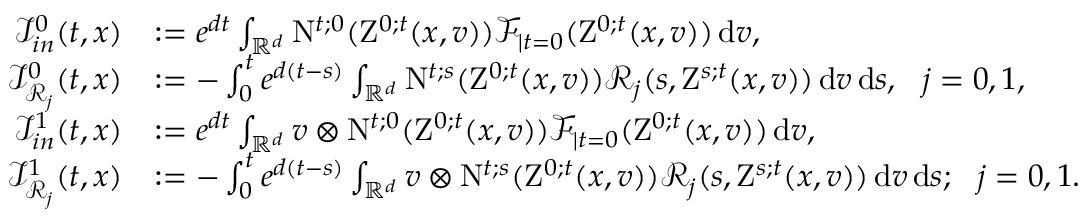Convert formula to latex. <formula><loc_0><loc_0><loc_500><loc_500>\begin{array} { r l } { \mathcal { I } _ { i n } ^ { 0 } ( t , x ) } & { \colon = e ^ { d t } \int _ { \mathbb { R } ^ { d } } N ^ { t ; 0 } ( Z ^ { 0 ; t } ( x , v ) ) \mathcal { F } _ { | t = 0 } ( Z ^ { 0 ; t } ( x , v ) ) \, d v , } \\ { \mathcal { I } _ { \mathcal { R } _ { j } } ^ { 0 } ( t , x ) } & { \colon = - \int _ { 0 } ^ { t } e ^ { d ( t - s ) } \int _ { \mathbb { R } ^ { d } } N ^ { t ; s } ( Z ^ { 0 ; t } ( x , v ) ) \mathcal { R } _ { j } ( s , Z ^ { s ; t } ( x , v ) ) \, d v \, d s , \ \ j = 0 , 1 , } \\ { \mathcal { I } _ { i n } ^ { 1 } ( t , x ) } & { \colon = e ^ { d t } \int _ { \mathbb { R } ^ { d } } v \otimes N ^ { t ; 0 } ( Z ^ { 0 ; t } ( x , v ) ) \mathcal { F } _ { | t = 0 } ( Z ^ { 0 ; t } ( x , v ) ) \, d v , } \\ { \mathcal { I } _ { \mathcal { R } _ { j } } ^ { 1 } ( t , x ) } & { \colon = - \int _ { 0 } ^ { t } e ^ { d ( t - s ) } \int _ { \mathbb { R } ^ { d } } v \otimes N ^ { t ; s } ( Z ^ { 0 ; t } ( x , v ) ) \mathcal { R } _ { j } ( s , Z ^ { s ; t } ( x , v ) ) \, d v \, d s ; \ \ j = 0 , 1 . } \end{array}</formula> 